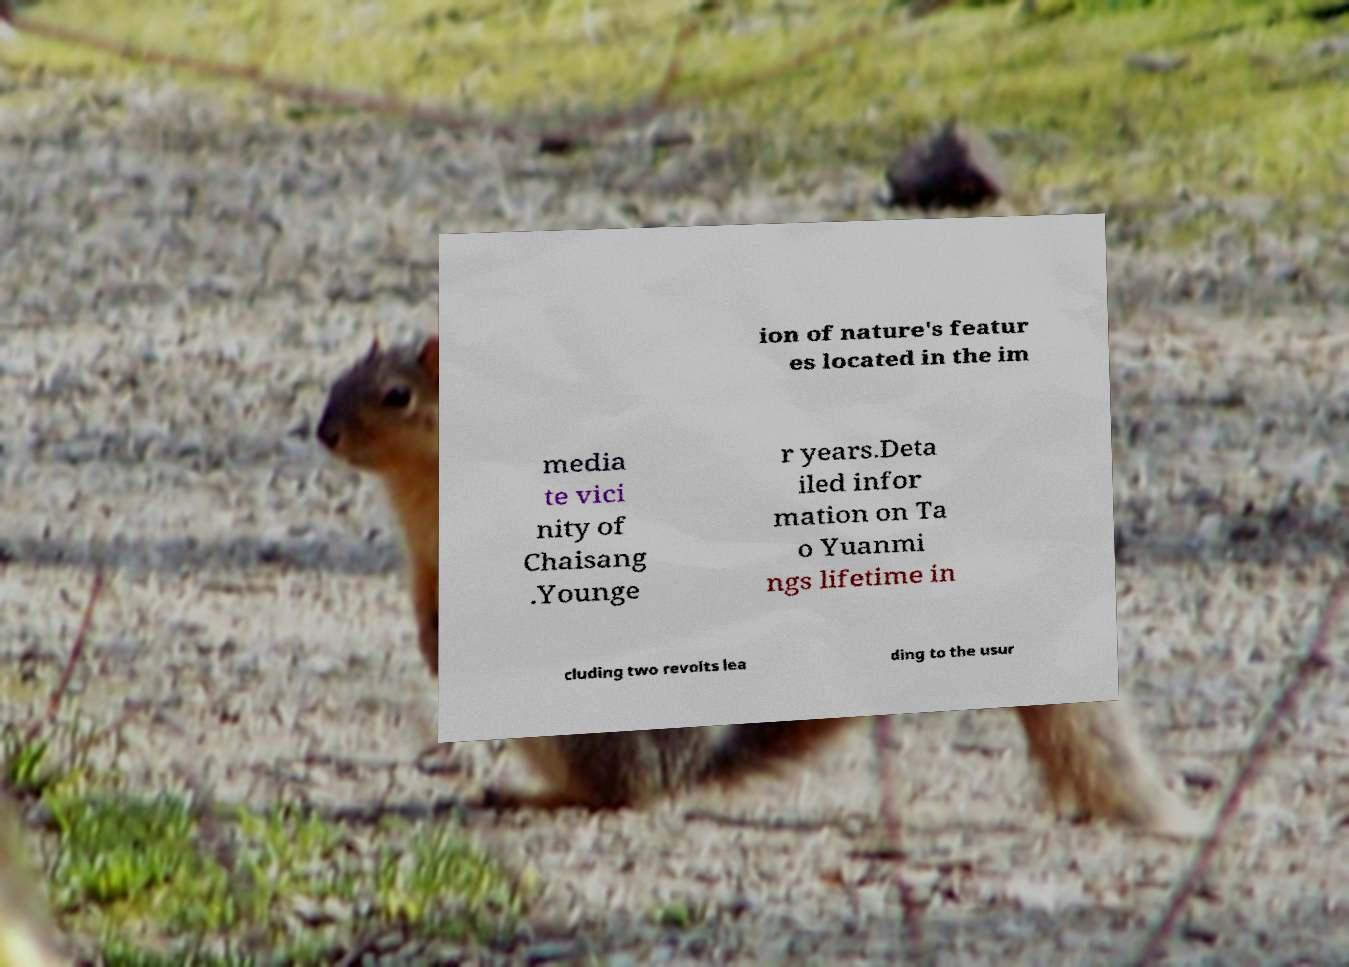What messages or text are displayed in this image? I need them in a readable, typed format. ion of nature's featur es located in the im media te vici nity of Chaisang .Younge r years.Deta iled infor mation on Ta o Yuanmi ngs lifetime in cluding two revolts lea ding to the usur 